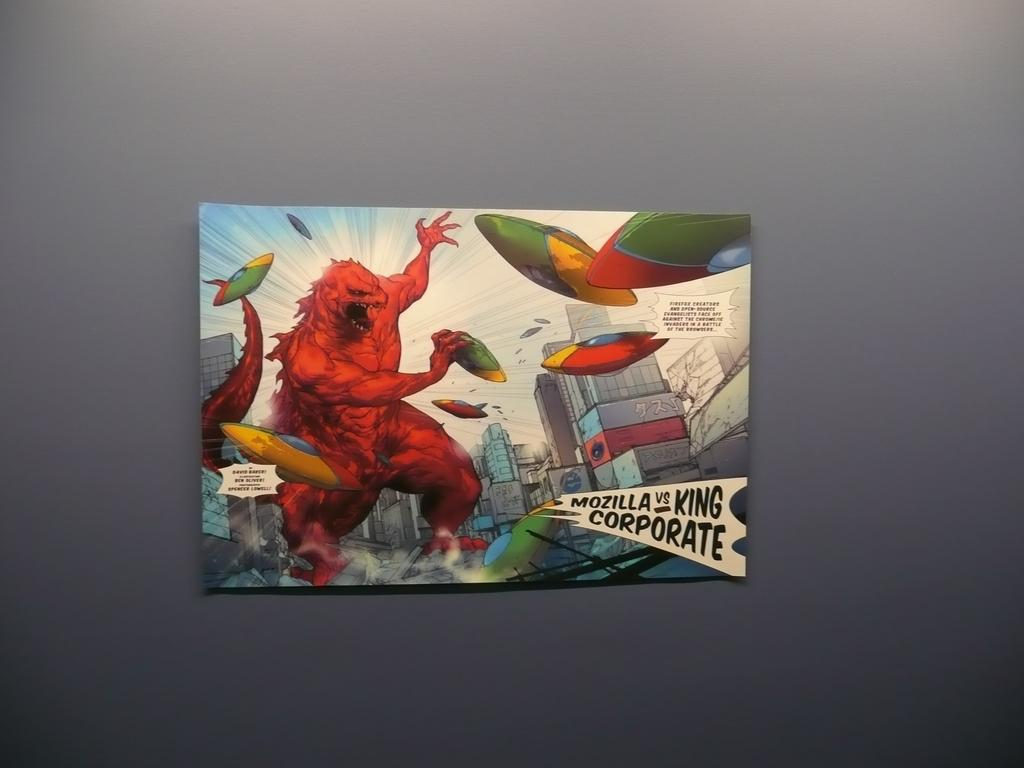<image>
Describe the image concisely. Mozilla fighting off different people from King Corporate 